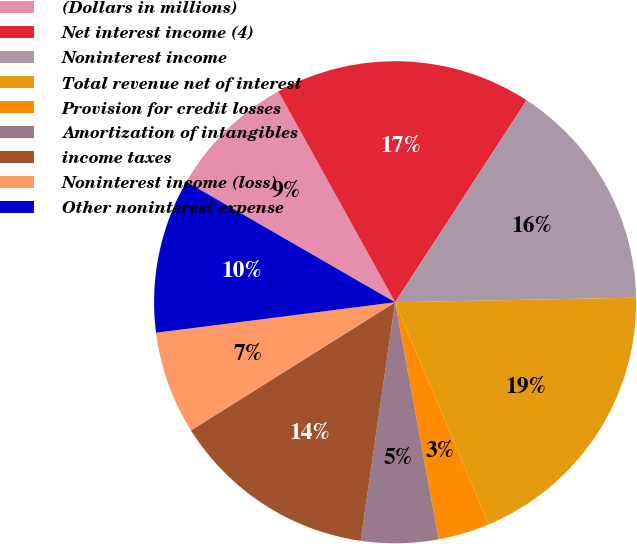<chart> <loc_0><loc_0><loc_500><loc_500><pie_chart><fcel>(Dollars in millions)<fcel>Net interest income (4)<fcel>Noninterest income<fcel>Total revenue net of interest<fcel>Provision for credit losses<fcel>Amortization of intangibles<fcel>income taxes<fcel>Noninterest income (loss)<fcel>Other noninterest expense<nl><fcel>8.62%<fcel>17.23%<fcel>15.51%<fcel>18.95%<fcel>3.46%<fcel>5.18%<fcel>13.79%<fcel>6.9%<fcel>10.35%<nl></chart> 